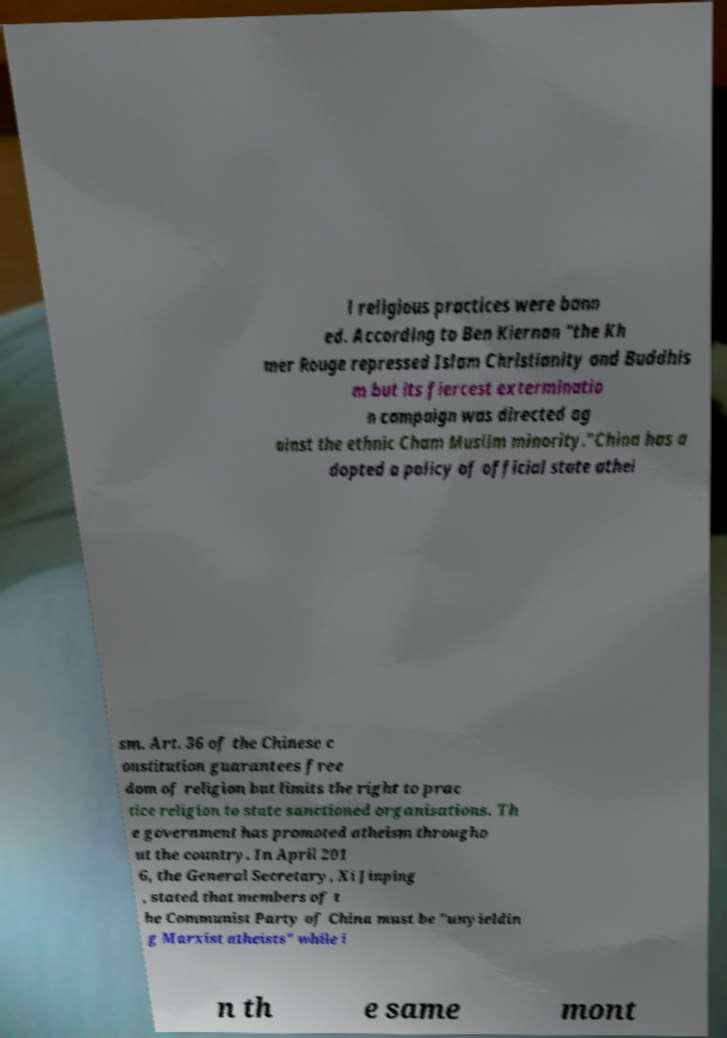There's text embedded in this image that I need extracted. Can you transcribe it verbatim? l religious practices were bann ed. According to Ben Kiernan "the Kh mer Rouge repressed Islam Christianity and Buddhis m but its fiercest exterminatio n campaign was directed ag ainst the ethnic Cham Muslim minority."China has a dopted a policy of official state athei sm. Art. 36 of the Chinese c onstitution guarantees free dom of religion but limits the right to prac tice religion to state sanctioned organisations. Th e government has promoted atheism througho ut the country. In April 201 6, the General Secretary, Xi Jinping , stated that members of t he Communist Party of China must be "unyieldin g Marxist atheists" while i n th e same mont 